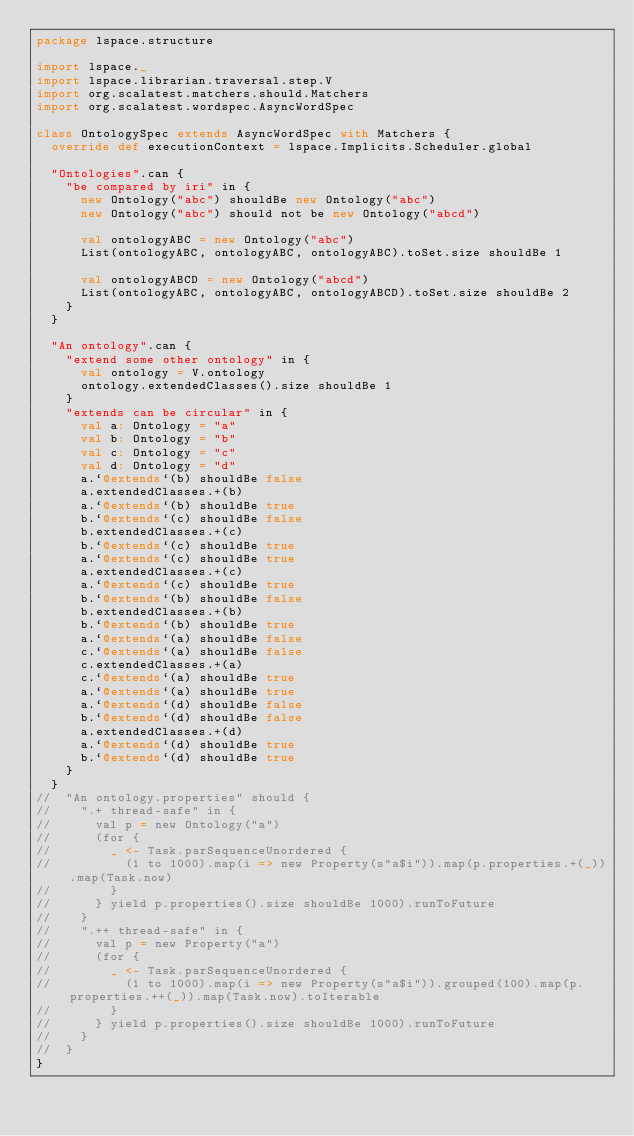Convert code to text. <code><loc_0><loc_0><loc_500><loc_500><_Scala_>package lspace.structure

import lspace._
import lspace.librarian.traversal.step.V
import org.scalatest.matchers.should.Matchers
import org.scalatest.wordspec.AsyncWordSpec

class OntologySpec extends AsyncWordSpec with Matchers {
  override def executionContext = lspace.Implicits.Scheduler.global

  "Ontologies".can {
    "be compared by iri" in {
      new Ontology("abc") shouldBe new Ontology("abc")
      new Ontology("abc") should not be new Ontology("abcd")

      val ontologyABC = new Ontology("abc")
      List(ontologyABC, ontologyABC, ontologyABC).toSet.size shouldBe 1

      val ontologyABCD = new Ontology("abcd")
      List(ontologyABC, ontologyABC, ontologyABCD).toSet.size shouldBe 2
    }
  }

  "An ontology".can {
    "extend some other ontology" in {
      val ontology = V.ontology
      ontology.extendedClasses().size shouldBe 1
    }
    "extends can be circular" in {
      val a: Ontology = "a"
      val b: Ontology = "b"
      val c: Ontology = "c"
      val d: Ontology = "d"
      a.`@extends`(b) shouldBe false
      a.extendedClasses.+(b)
      a.`@extends`(b) shouldBe true
      b.`@extends`(c) shouldBe false
      b.extendedClasses.+(c)
      b.`@extends`(c) shouldBe true
      a.`@extends`(c) shouldBe true
      a.extendedClasses.+(c)
      a.`@extends`(c) shouldBe true
      b.`@extends`(b) shouldBe false
      b.extendedClasses.+(b)
      b.`@extends`(b) shouldBe true
      a.`@extends`(a) shouldBe false
      c.`@extends`(a) shouldBe false
      c.extendedClasses.+(a)
      c.`@extends`(a) shouldBe true
      a.`@extends`(a) shouldBe true
      a.`@extends`(d) shouldBe false
      b.`@extends`(d) shouldBe false
      a.extendedClasses.+(d)
      a.`@extends`(d) shouldBe true
      b.`@extends`(d) shouldBe true
    }
  }
//  "An ontology.properties" should {
//    ".+ thread-safe" in {
//      val p = new Ontology("a")
//      (for {
//        _ <- Task.parSequenceUnordered {
//          (1 to 1000).map(i => new Property(s"a$i")).map(p.properties.+(_)).map(Task.now)
//        }
//      } yield p.properties().size shouldBe 1000).runToFuture
//    }
//    ".++ thread-safe" in {
//      val p = new Property("a")
//      (for {
//        _ <- Task.parSequenceUnordered {
//          (1 to 1000).map(i => new Property(s"a$i")).grouped(100).map(p.properties.++(_)).map(Task.now).toIterable
//        }
//      } yield p.properties().size shouldBe 1000).runToFuture
//    }
//  }
}
</code> 